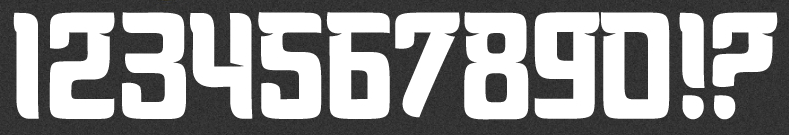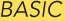Identify the words shown in these images in order, separated by a semicolon. 1234567890!?; BASIC 